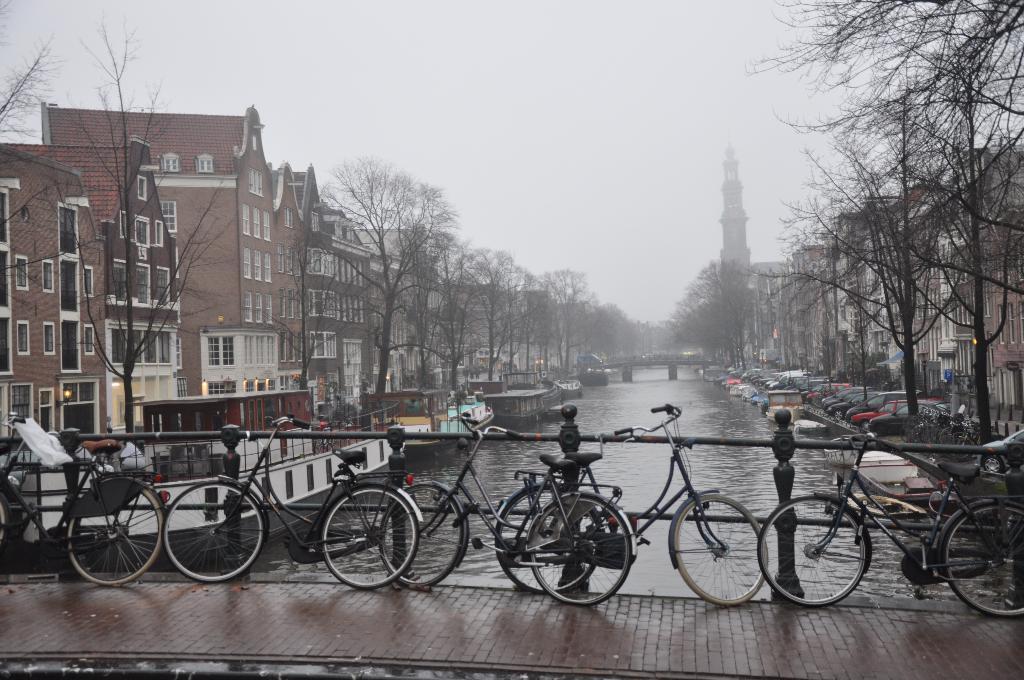Could you give a brief overview of what you see in this image? In this picture we can see there are bicycles and iron grilles. Behind the bicycles there are boats on the water. On the right side of the boats there are vehicles parked on the road. Behind the boats there is a bridge. On the left and right side of the boats there are trees and buildings. Behind the buildings there is the sky. 